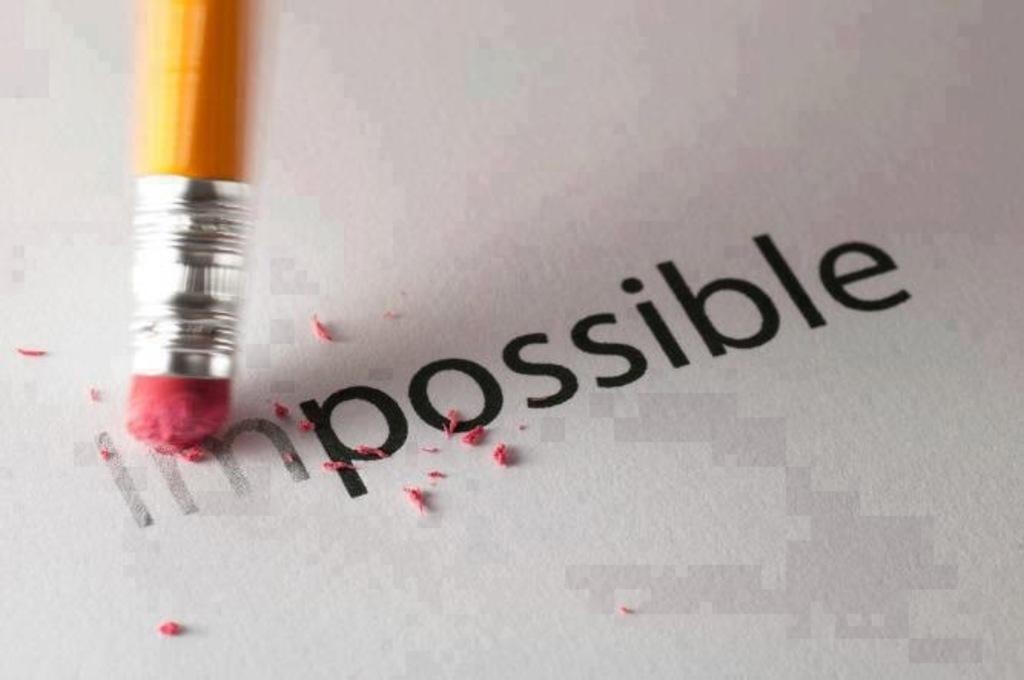What stationery items can be seen in the image? There is a pencil and an eraser in the image. What might the pencil and eraser be used for? They might be used for writing or drawing on the paper, which is also visible in the image. Is there a dock visible in the image? No, there is no dock present in the image. 